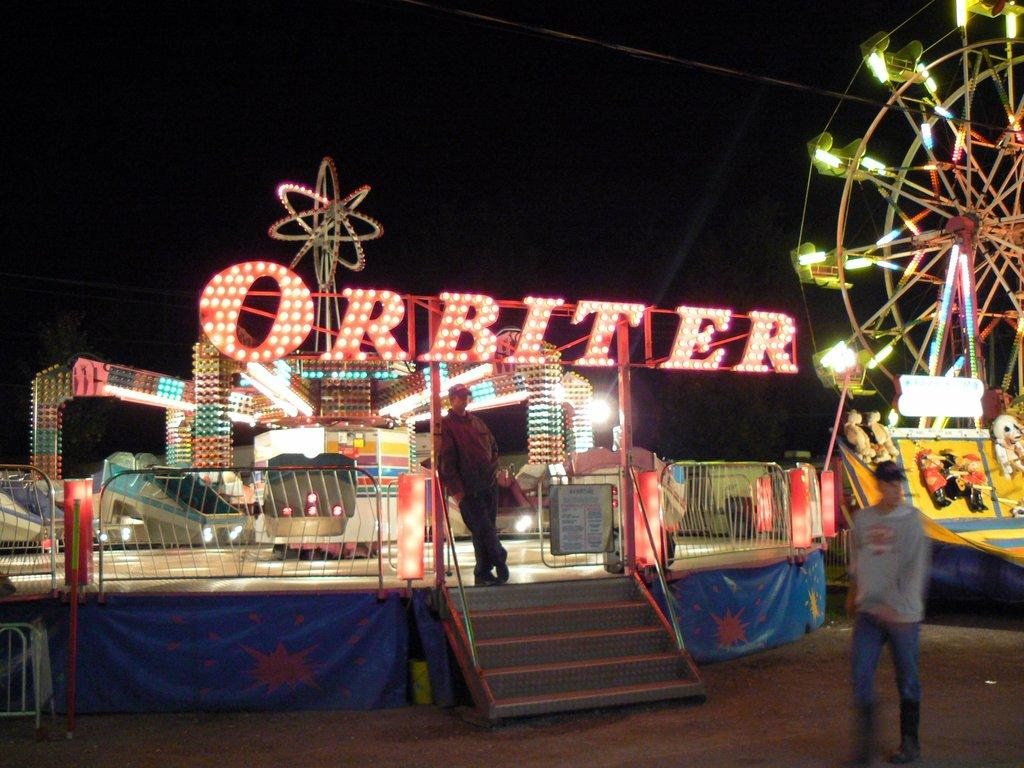What type of location is depicted in the image? The image appears to be of an amusement park. What can be seen at the amusement park? There are rides visible in the image. Is there any text present in the image? Yes, there is text present in the image. What are the actions of the people in the image? A man is walking, and another man is standing in the image. How would you describe the lighting in the image? The background of the image is dark. What type of marble is being used to make decisions in the image? There is no marble or decision-making process depicted in the image. Can you tell me how much milk the man is holding in the image? There is no milk or any indication of a container for milk in the image. 